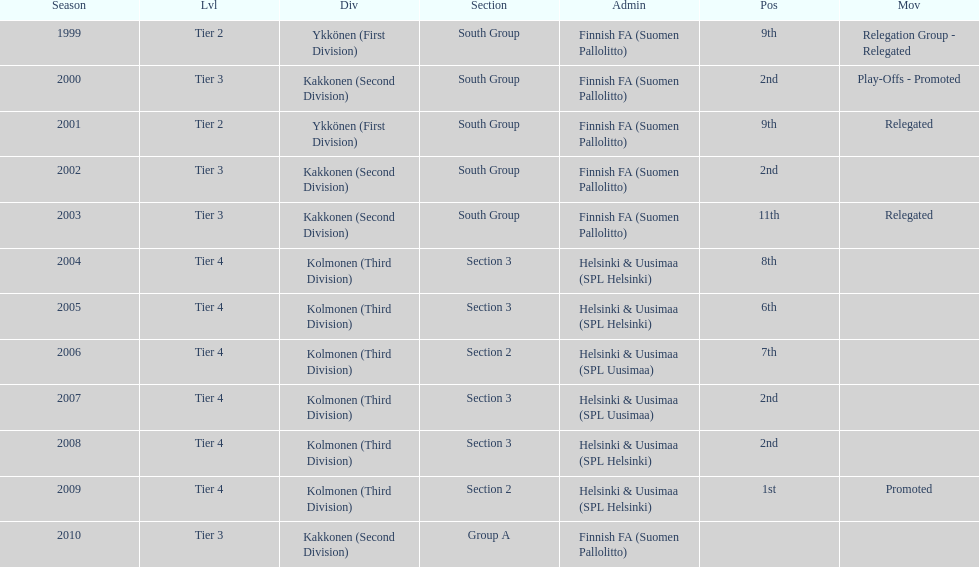Which administration has the least amount of division? Helsinki & Uusimaa (SPL Helsinki). 